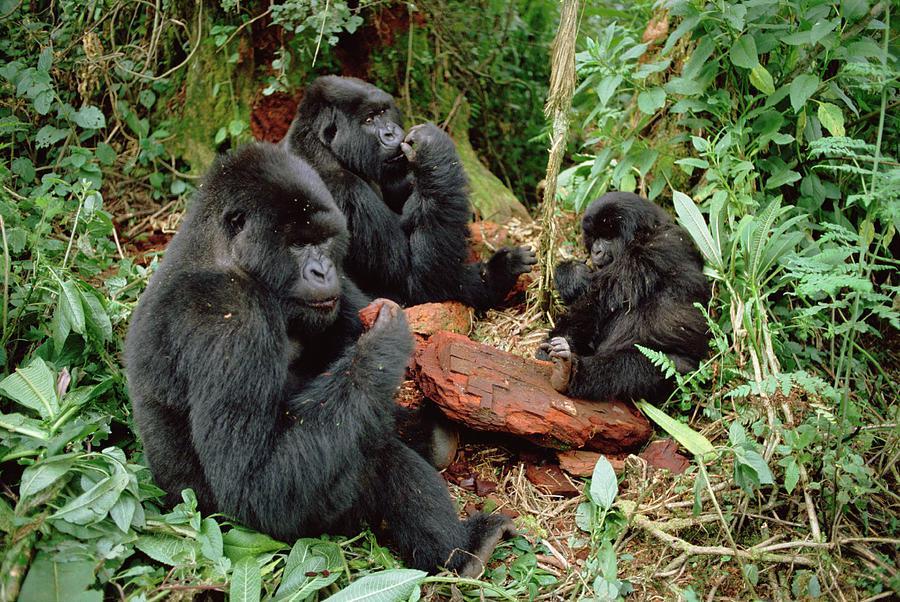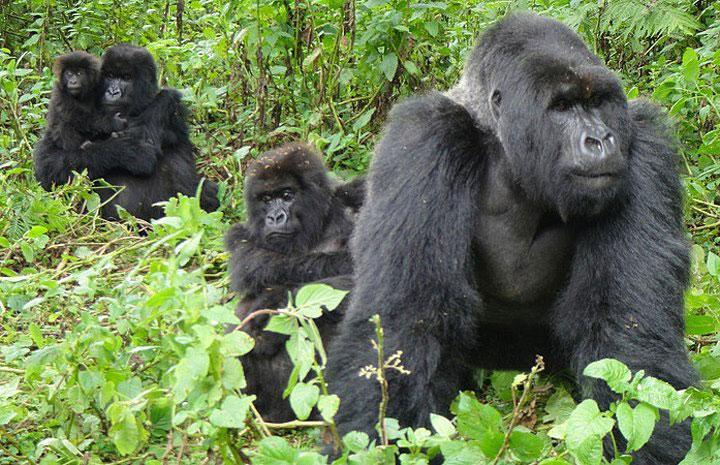The first image is the image on the left, the second image is the image on the right. Considering the images on both sides, is "Right image shows exactly two apes, a baby grasping an adult." valid? Answer yes or no. No. The first image is the image on the left, the second image is the image on the right. Evaluate the accuracy of this statement regarding the images: "There are a total of 5 gorillas with one being a baby being elevated off of the ground by an adult gorilla.". Is it true? Answer yes or no. No. 